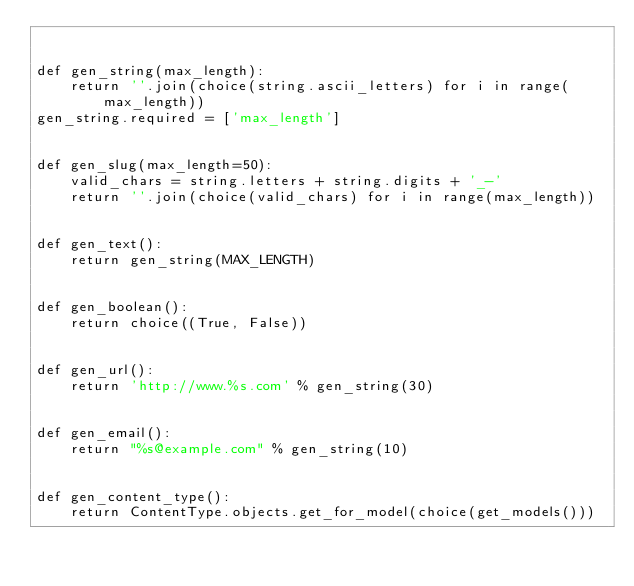Convert code to text. <code><loc_0><loc_0><loc_500><loc_500><_Python_>

def gen_string(max_length):
    return ''.join(choice(string.ascii_letters) for i in range(max_length))
gen_string.required = ['max_length']


def gen_slug(max_length=50):
    valid_chars = string.letters + string.digits + '_-'
    return ''.join(choice(valid_chars) for i in range(max_length))


def gen_text():
    return gen_string(MAX_LENGTH)


def gen_boolean():
    return choice((True, False))


def gen_url():
    return 'http://www.%s.com' % gen_string(30)


def gen_email():
    return "%s@example.com" % gen_string(10)


def gen_content_type():
    return ContentType.objects.get_for_model(choice(get_models()))
</code> 